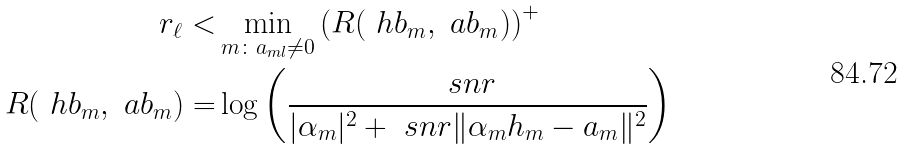Convert formula to latex. <formula><loc_0><loc_0><loc_500><loc_500>r _ { \ell } < & \min _ { m \colon a _ { m l } \neq 0 } \left ( R ( \ h b _ { m } , \ a b _ { m } ) \right ) ^ { + } \\ R ( \ h b _ { m } , \ a b _ { m } ) = & \log \left ( \frac { \ s n r } { | \alpha _ { m } | ^ { 2 } + \ s n r \| \alpha _ { m } h _ { m } - a _ { m } \| ^ { 2 } } \right )</formula> 